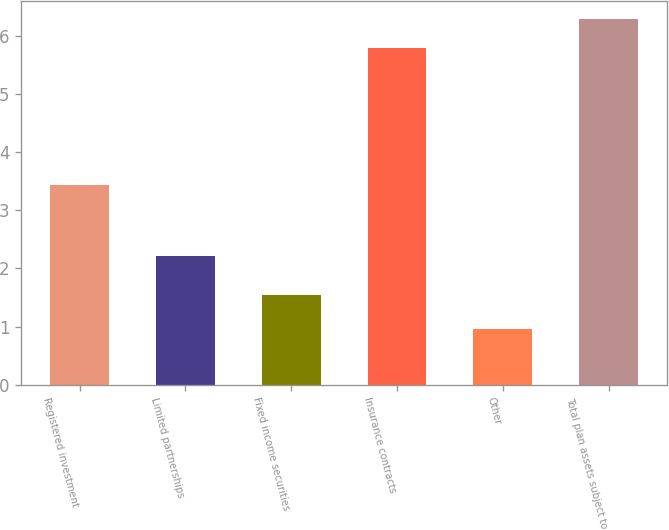<chart> <loc_0><loc_0><loc_500><loc_500><bar_chart><fcel>Registered investment<fcel>Limited partnerships<fcel>Fixed income securities<fcel>Insurance contracts<fcel>Other<fcel>Total plan assets subject to<nl><fcel>3.44<fcel>2.22<fcel>1.54<fcel>5.8<fcel>0.95<fcel>6.29<nl></chart> 